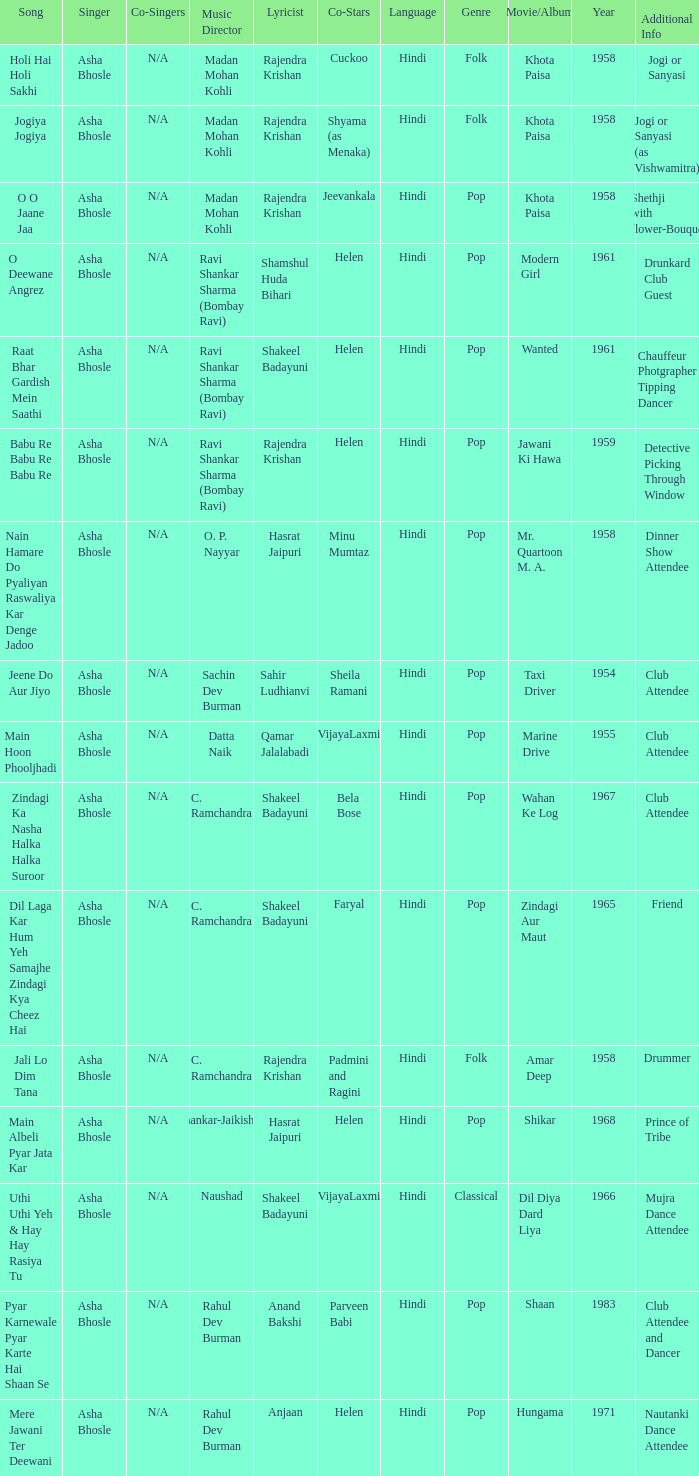What movie did Bela Bose co-star in? Wahan Ke Log. 